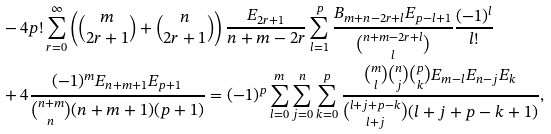<formula> <loc_0><loc_0><loc_500><loc_500>& - 4 p ! \sum _ { r = 0 } ^ { \infty } \left ( \binom { m } { 2 r + 1 } + \binom { n } { 2 r + 1 } \right ) \frac { E _ { 2 r + 1 } } { n + m - 2 r } \sum _ { l = 1 } ^ { p } \frac { B _ { m + n - 2 r + l } E _ { p - l + 1 } } { \binom { n + m - 2 r + l } { l } } \frac { ( - 1 ) ^ { l } } { l ! } \\ & + 4 \frac { ( - 1 ) ^ { m } E _ { n + m + 1 } E _ { p + 1 } } { \binom { n + m } { n } ( n + m + 1 ) ( p + 1 ) } = ( - 1 ) ^ { p } \sum _ { l = 0 } ^ { m } \sum _ { j = 0 } ^ { n } \sum _ { k = 0 } ^ { p } \frac { \binom { m } { l } \binom { n } { j } \binom { p } { k } E _ { m - l } E _ { n - j } E _ { k } } { \binom { l + j + p - k } { l + j } ( l + j + p - k + 1 ) } ,</formula> 